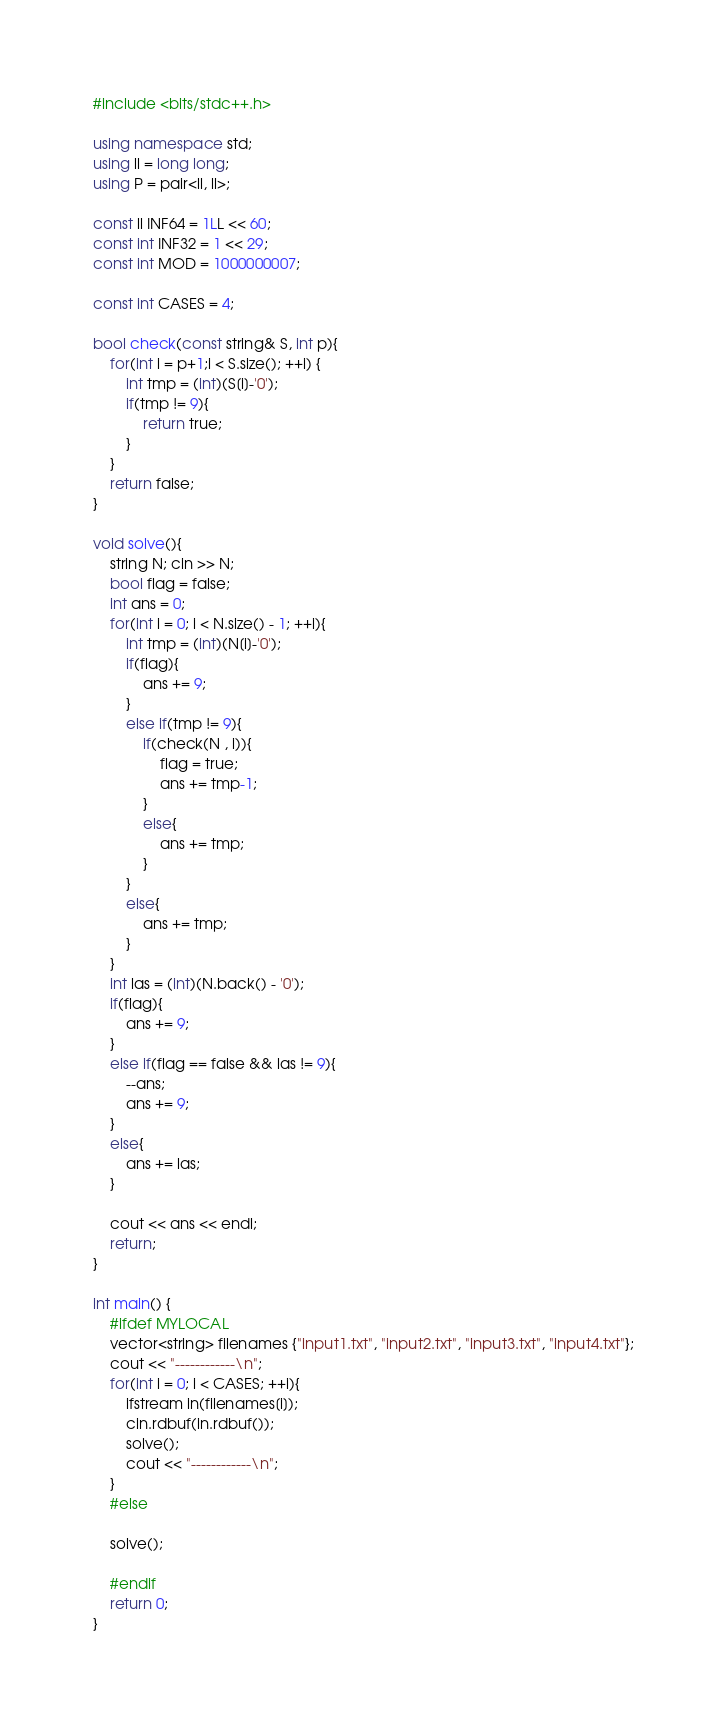Convert code to text. <code><loc_0><loc_0><loc_500><loc_500><_C++_>#include <bits/stdc++.h>

using namespace std;
using ll = long long;
using P = pair<ll, ll>;

const ll INF64 = 1LL << 60;
const int INF32 = 1 << 29;
const int MOD = 1000000007;

const int CASES = 4;

bool check(const string& S, int p){
    for(int i = p+1;i < S.size(); ++i) {
        int tmp = (int)(S[i]-'0');
        if(tmp != 9){
            return true;
        }
    }
    return false;
}

void solve(){
    string N; cin >> N;
    bool flag = false;
    int ans = 0;
    for(int i = 0; i < N.size() - 1; ++i){
        int tmp = (int)(N[i]-'0');
        if(flag){
            ans += 9;
        }
        else if(tmp != 9){
            if(check(N , i)){
                flag = true;
                ans += tmp-1;
            }
            else{
                ans += tmp;
            }
        }
        else{
            ans += tmp;
        }
    }
    int las = (int)(N.back() - '0');
    if(flag){
        ans += 9;
    }
    else if(flag == false && las != 9){
        --ans;
        ans += 9;
    }
    else{
        ans += las;
    }

    cout << ans << endl;
    return;
}

int main() {
    #ifdef MYLOCAL
    vector<string> filenames {"input1.txt", "input2.txt", "input3.txt", "input4.txt"};
    cout << "------------\n";
    for(int i = 0; i < CASES; ++i){
        ifstream in(filenames[i]);
        cin.rdbuf(in.rdbuf());
        solve();
        cout << "------------\n";
    }
    #else

    solve();

    #endif
    return 0;
}

</code> 